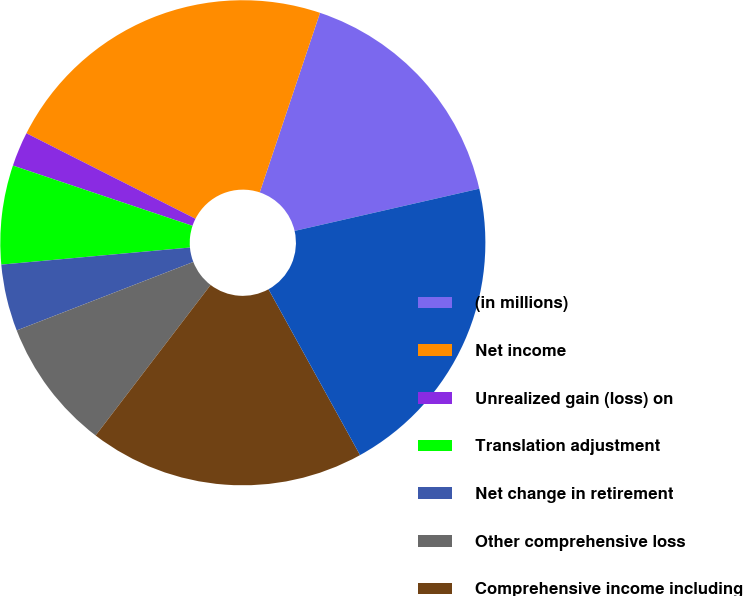Convert chart. <chart><loc_0><loc_0><loc_500><loc_500><pie_chart><fcel>(in millions)<fcel>Net income<fcel>Unrealized gain (loss) on<fcel>Translation adjustment<fcel>Net change in retirement<fcel>Other comprehensive loss<fcel>Comprehensive income including<fcel>Comprehensive income<nl><fcel>16.27%<fcel>22.7%<fcel>2.3%<fcel>6.59%<fcel>4.45%<fcel>8.73%<fcel>18.41%<fcel>20.55%<nl></chart> 